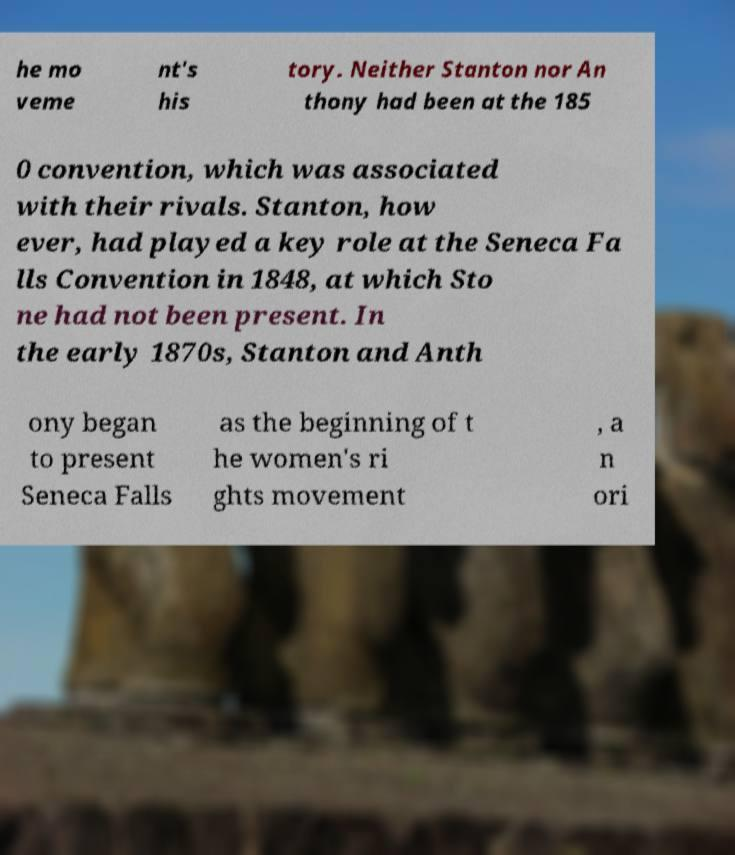There's text embedded in this image that I need extracted. Can you transcribe it verbatim? he mo veme nt's his tory. Neither Stanton nor An thony had been at the 185 0 convention, which was associated with their rivals. Stanton, how ever, had played a key role at the Seneca Fa lls Convention in 1848, at which Sto ne had not been present. In the early 1870s, Stanton and Anth ony began to present Seneca Falls as the beginning of t he women's ri ghts movement , a n ori 